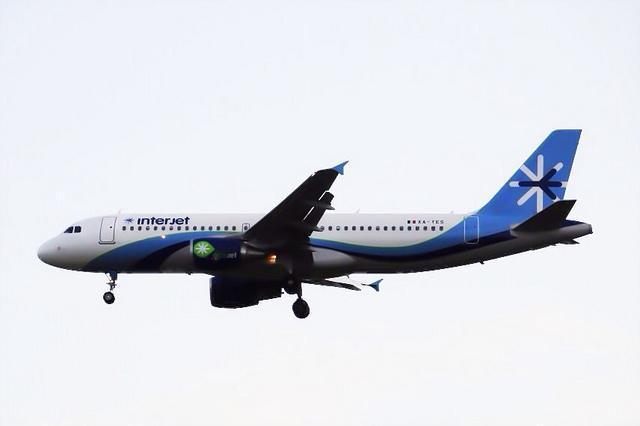How many engines are on the plane?
Give a very brief answer. 2. How many airplanes can be seen?
Give a very brief answer. 1. How many people are shown?
Give a very brief answer. 0. 